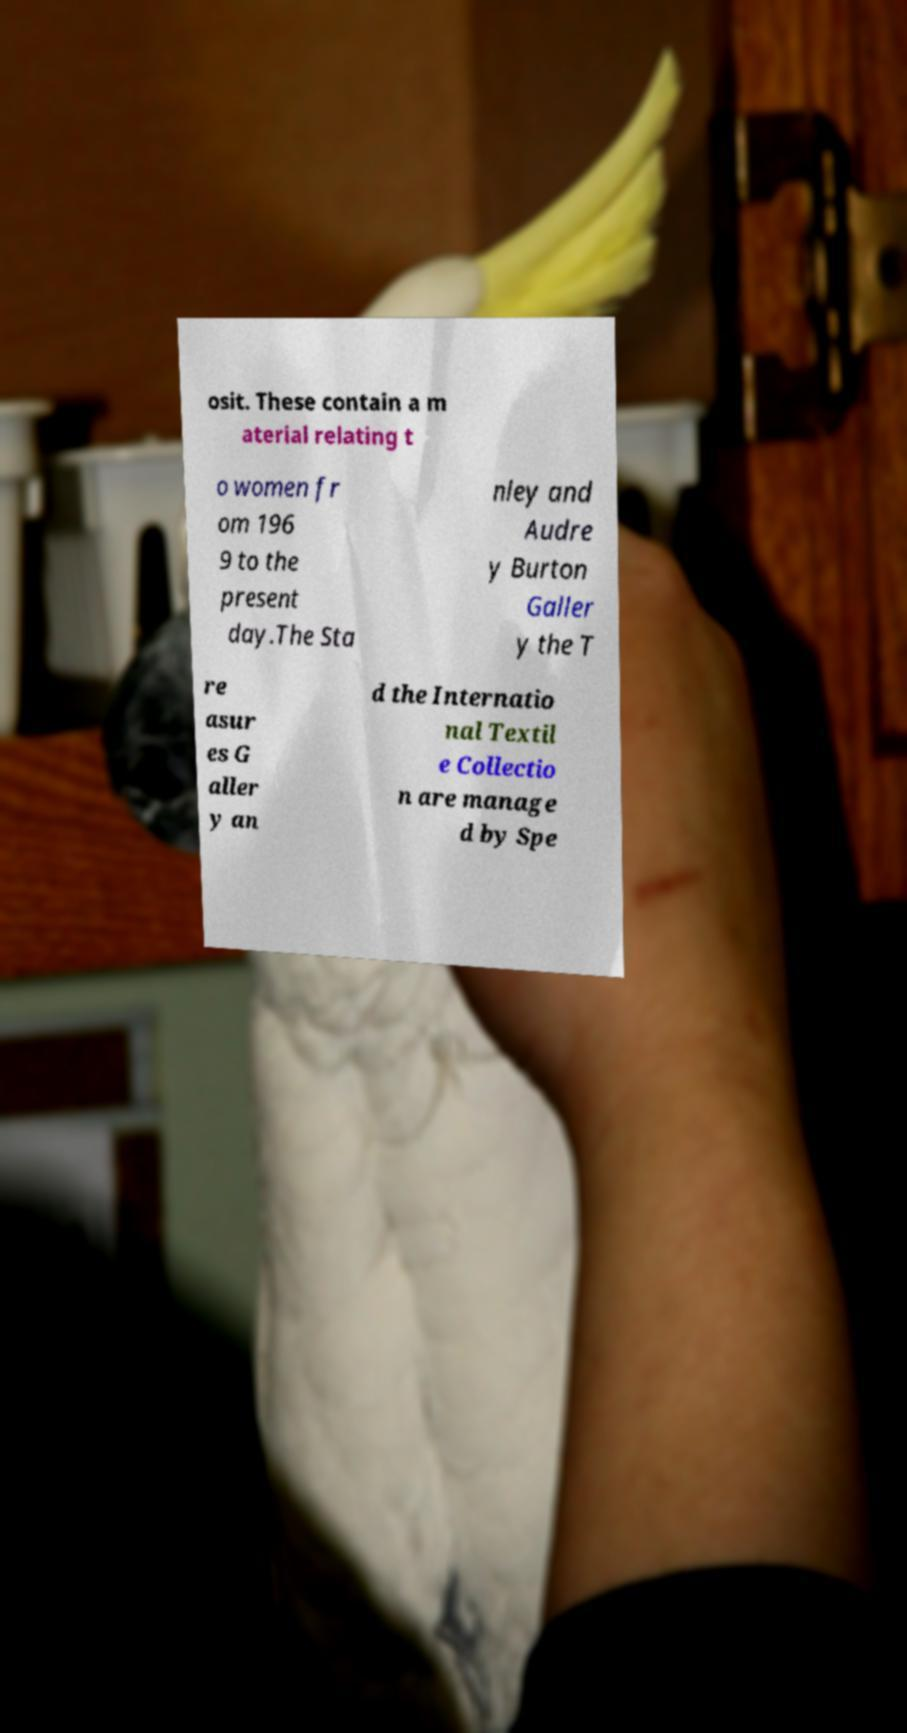For documentation purposes, I need the text within this image transcribed. Could you provide that? osit. These contain a m aterial relating t o women fr om 196 9 to the present day.The Sta nley and Audre y Burton Galler y the T re asur es G aller y an d the Internatio nal Textil e Collectio n are manage d by Spe 